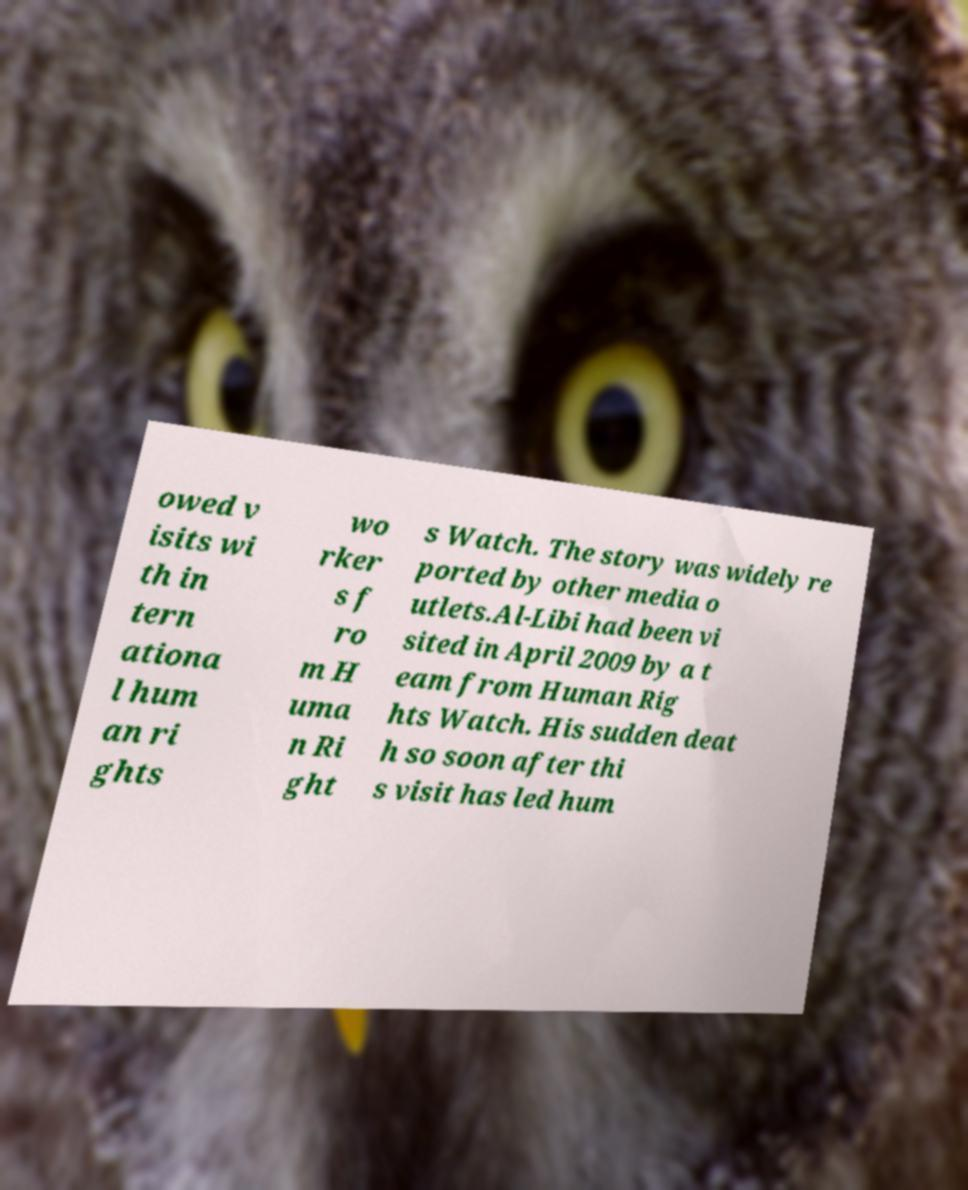I need the written content from this picture converted into text. Can you do that? owed v isits wi th in tern ationa l hum an ri ghts wo rker s f ro m H uma n Ri ght s Watch. The story was widely re ported by other media o utlets.Al-Libi had been vi sited in April 2009 by a t eam from Human Rig hts Watch. His sudden deat h so soon after thi s visit has led hum 